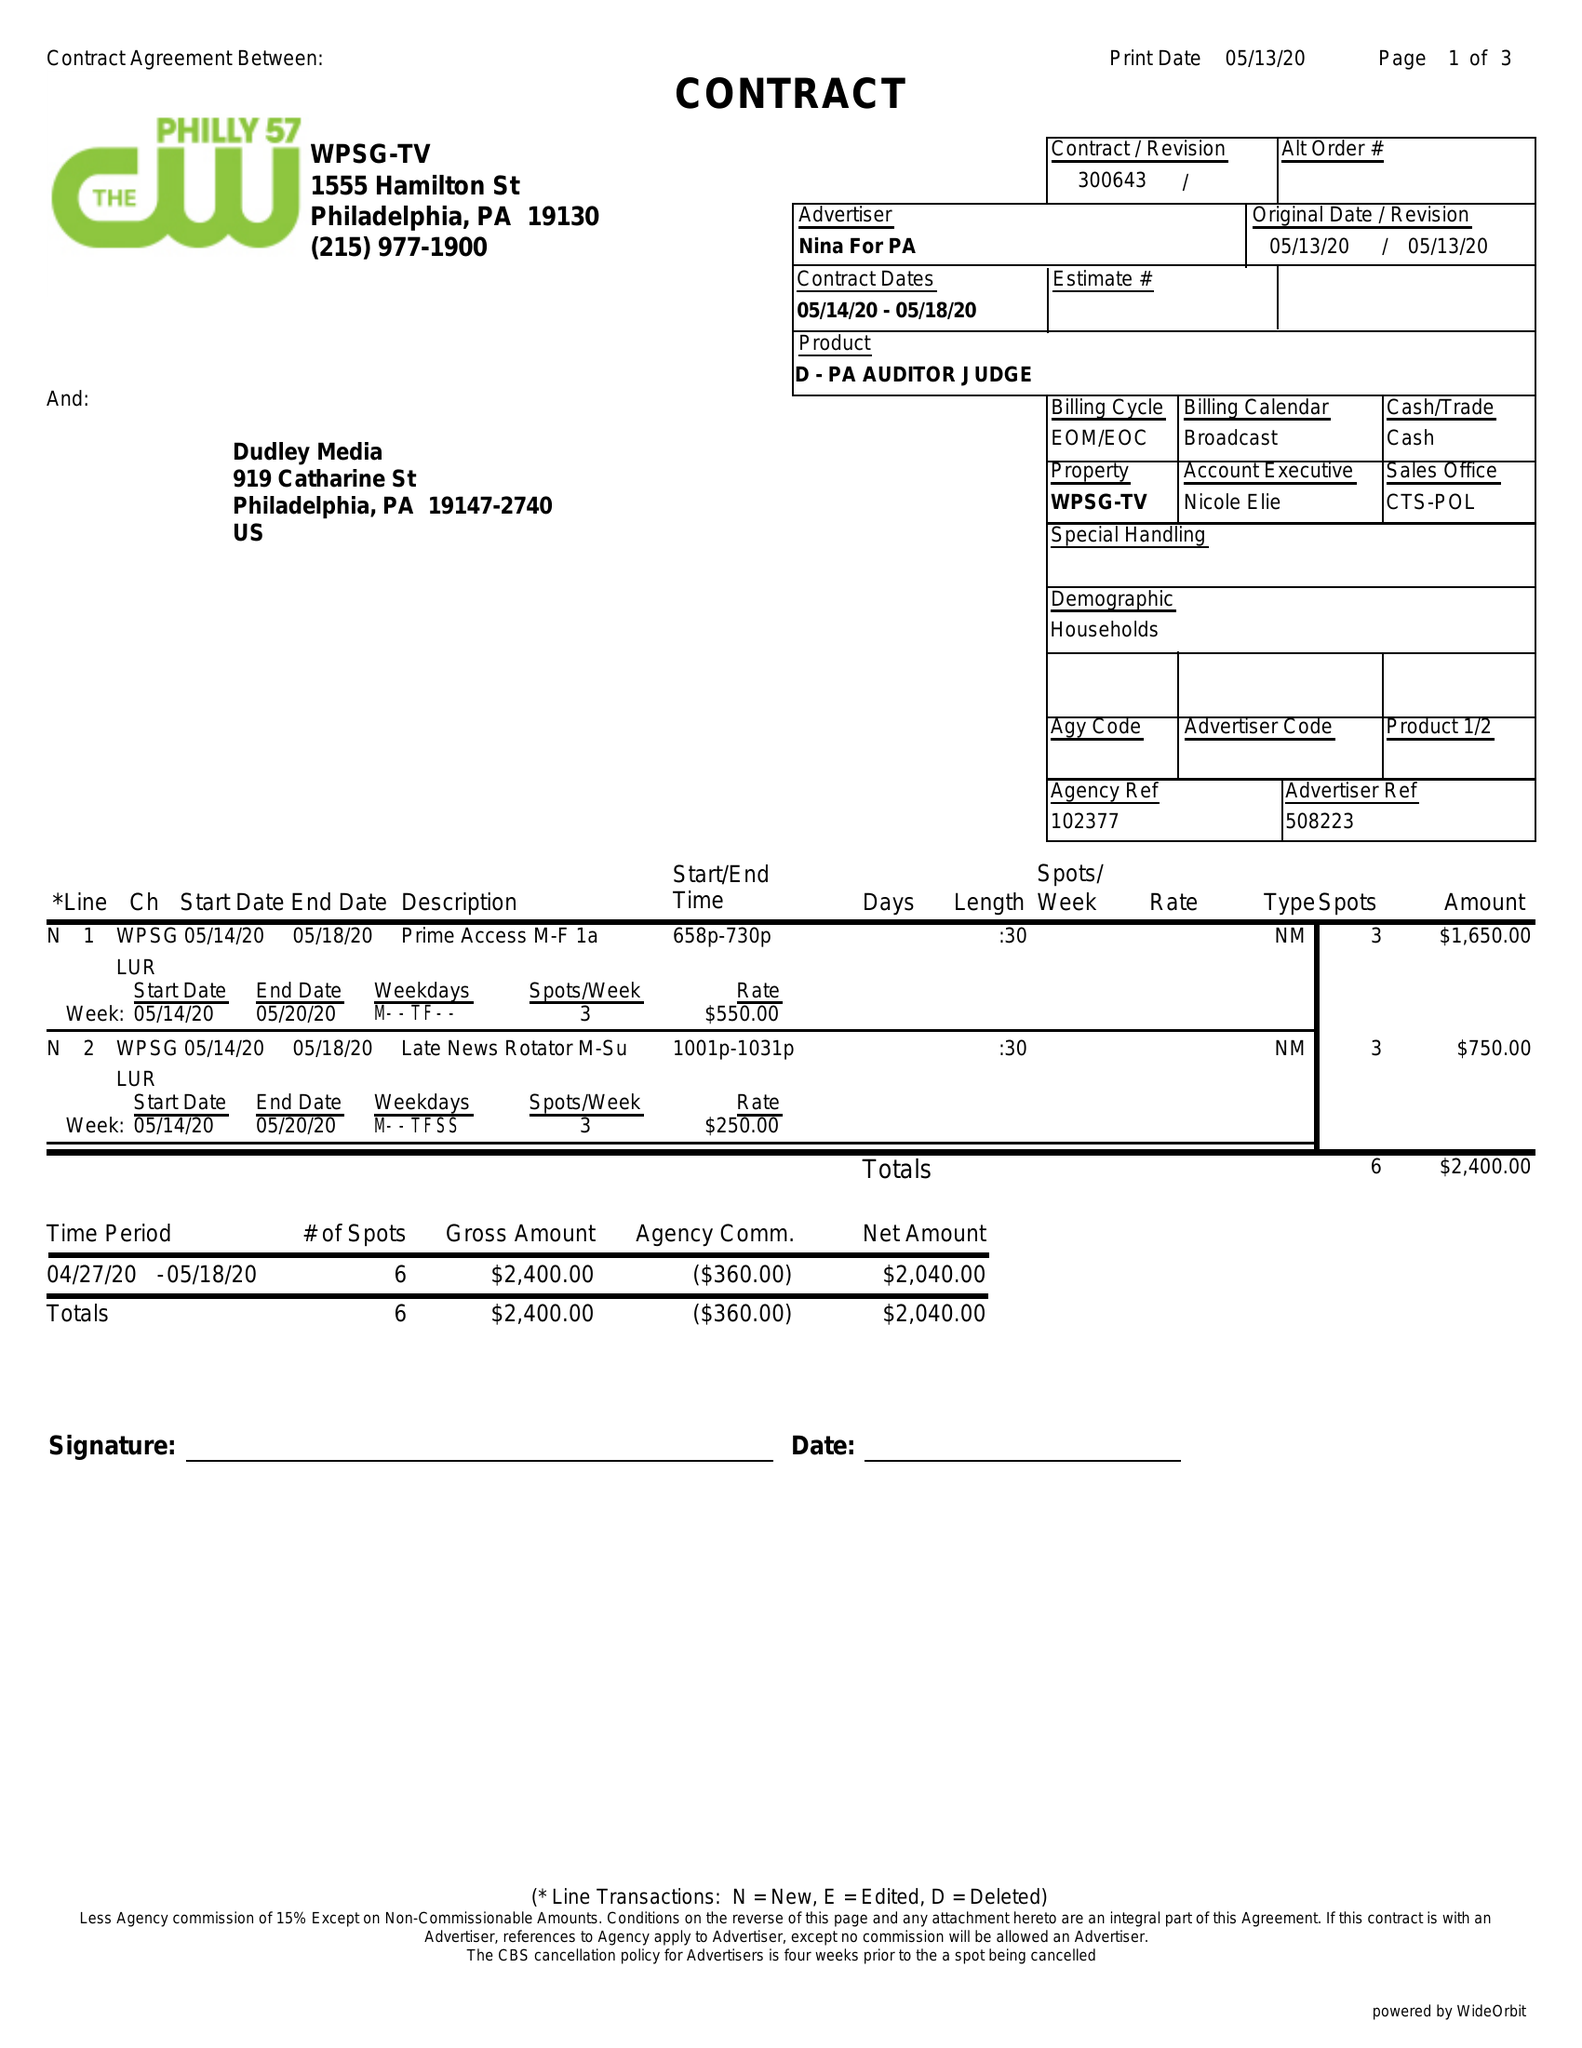What is the value for the flight_to?
Answer the question using a single word or phrase. 05/18/20 